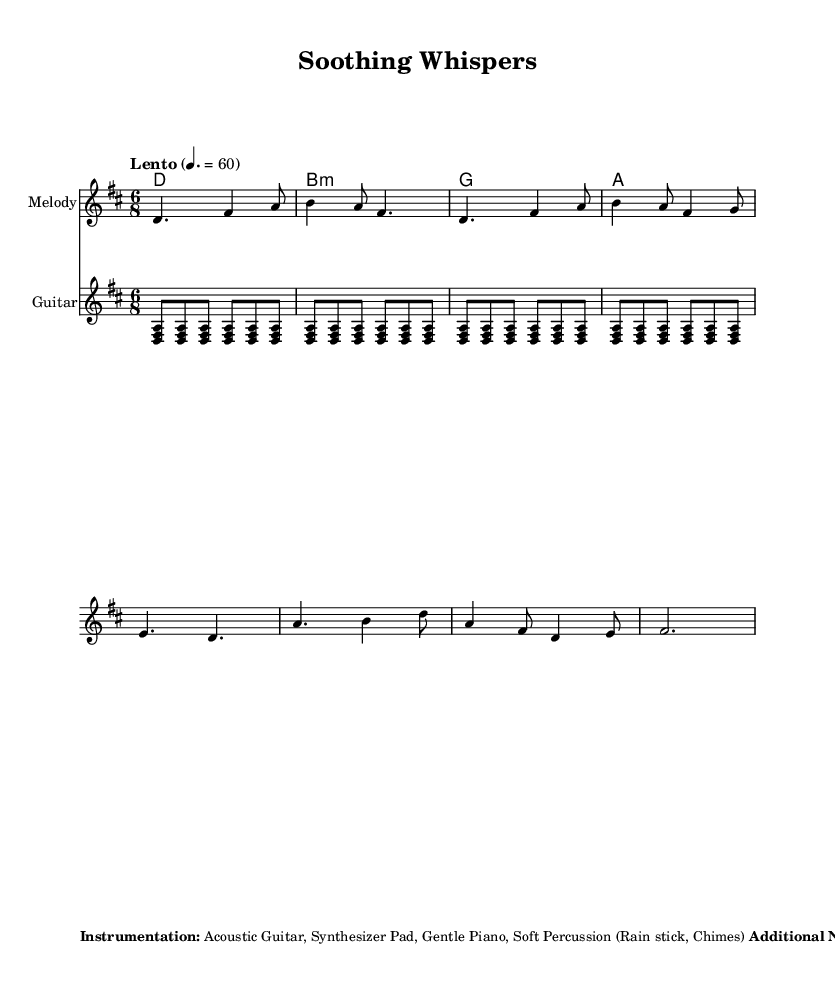What is the key signature of this music? The key signature is D major, indicated by the presence of two sharps (F# and C#).
Answer: D major What is the time signature of this music? The time signature is 6/8, which allows for six eighth notes per measure.
Answer: 6/8 What is the tempo marking for this piece? The tempo marking is "Lento," which indicates a slow and relaxed pace of 60 beats per minute.
Answer: Lento How many measures are there in the melody section? The melody section contains five measures, counting each distinct notation in the melody line.
Answer: Five measures Which instruments are included in the instrumentation? The instruments included are Acoustic Guitar, Synthesizer Pad, Gentle Piano, and Soft Percussion (Rain stick, Chimes).
Answer: Acoustic Guitar, Synthesizer Pad, Gentle Piano, Soft Percussion What dynamics should be used throughout the piece? The dynamics should be soft throughout, ranging between pianissimo to mezzo-piano.
Answer: Soft dynamics (pp to mp) How does the harmonic structure support the melody? The harmonic structure uses chord modes such as D major and variations that complement the melody, providing a soothing backdrop.
Answer: It uses D major and variations 